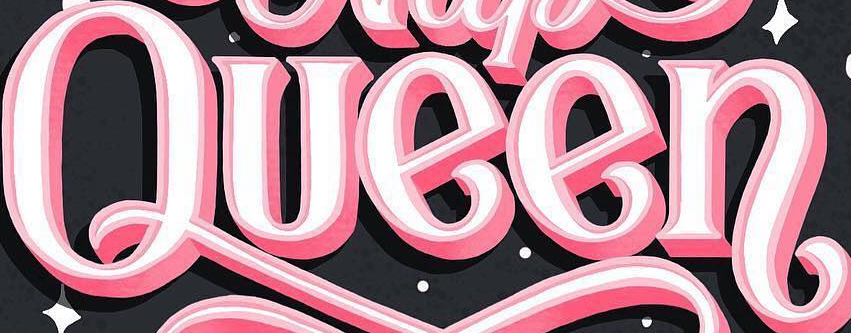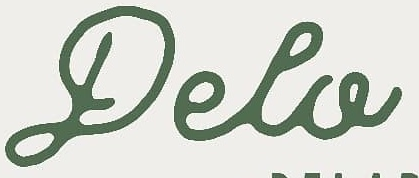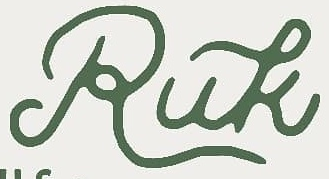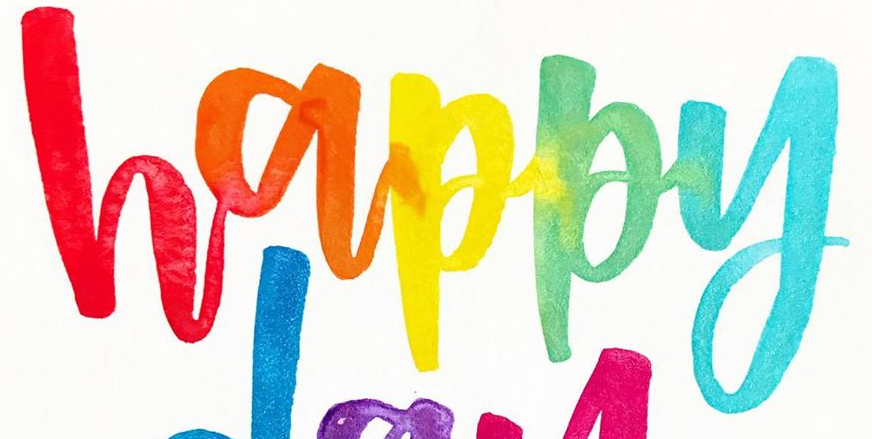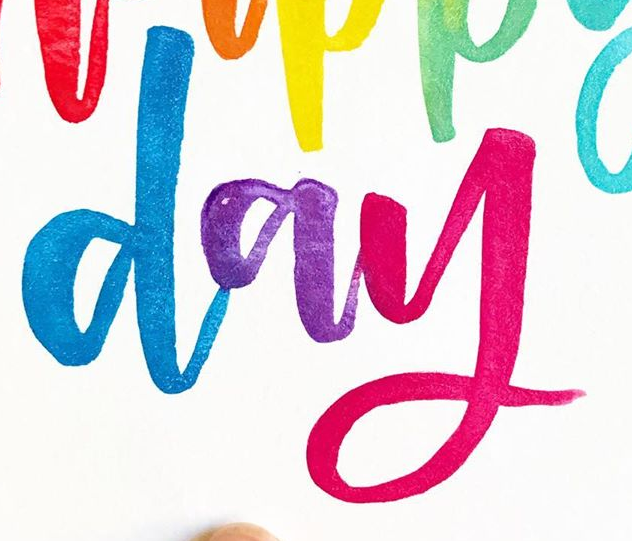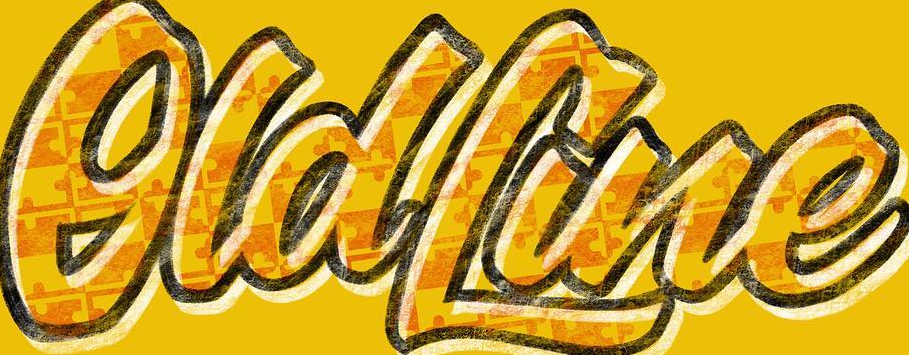Read the text from these images in sequence, separated by a semicolon. Queen; Pela; Ruk; happy; day; OldLine 